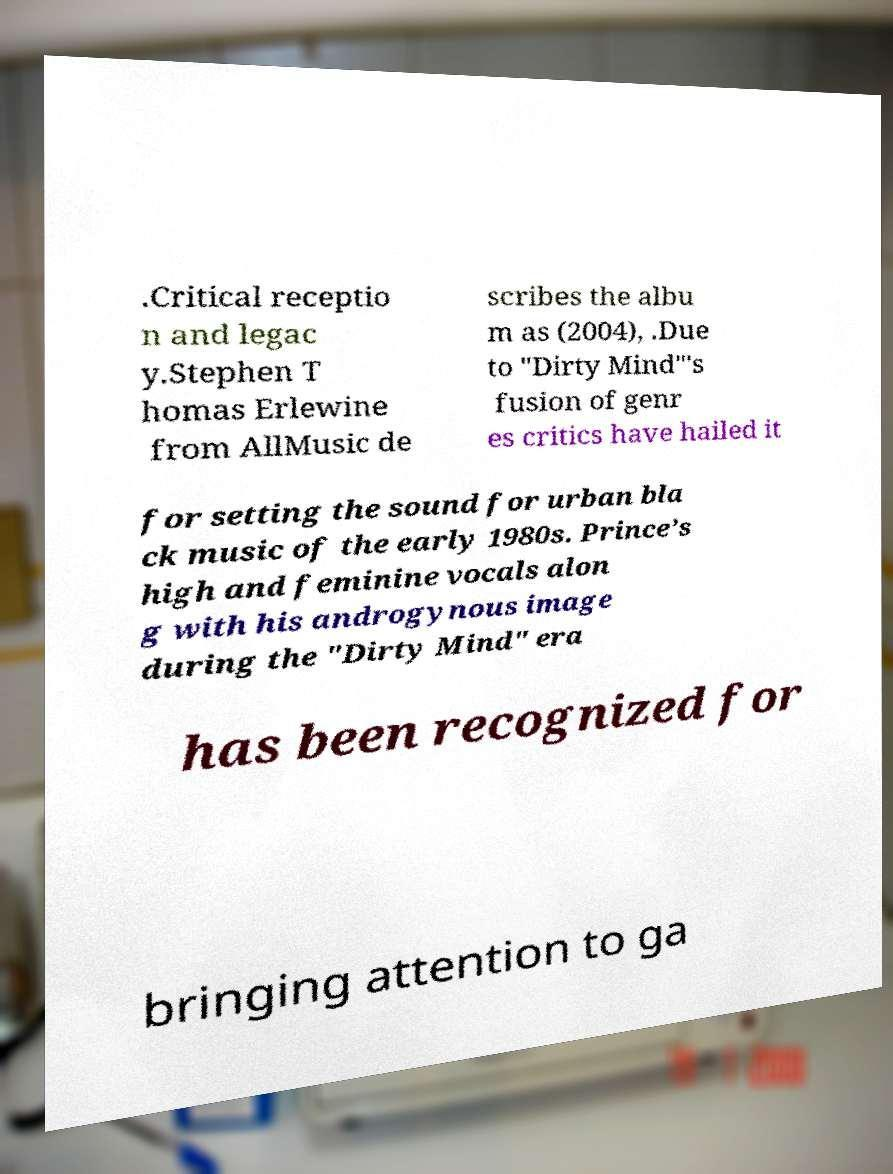Could you extract and type out the text from this image? .Critical receptio n and legac y.Stephen T homas Erlewine from AllMusic de scribes the albu m as (2004), .Due to "Dirty Mind"'s fusion of genr es critics have hailed it for setting the sound for urban bla ck music of the early 1980s. Prince’s high and feminine vocals alon g with his androgynous image during the "Dirty Mind" era has been recognized for bringing attention to ga 